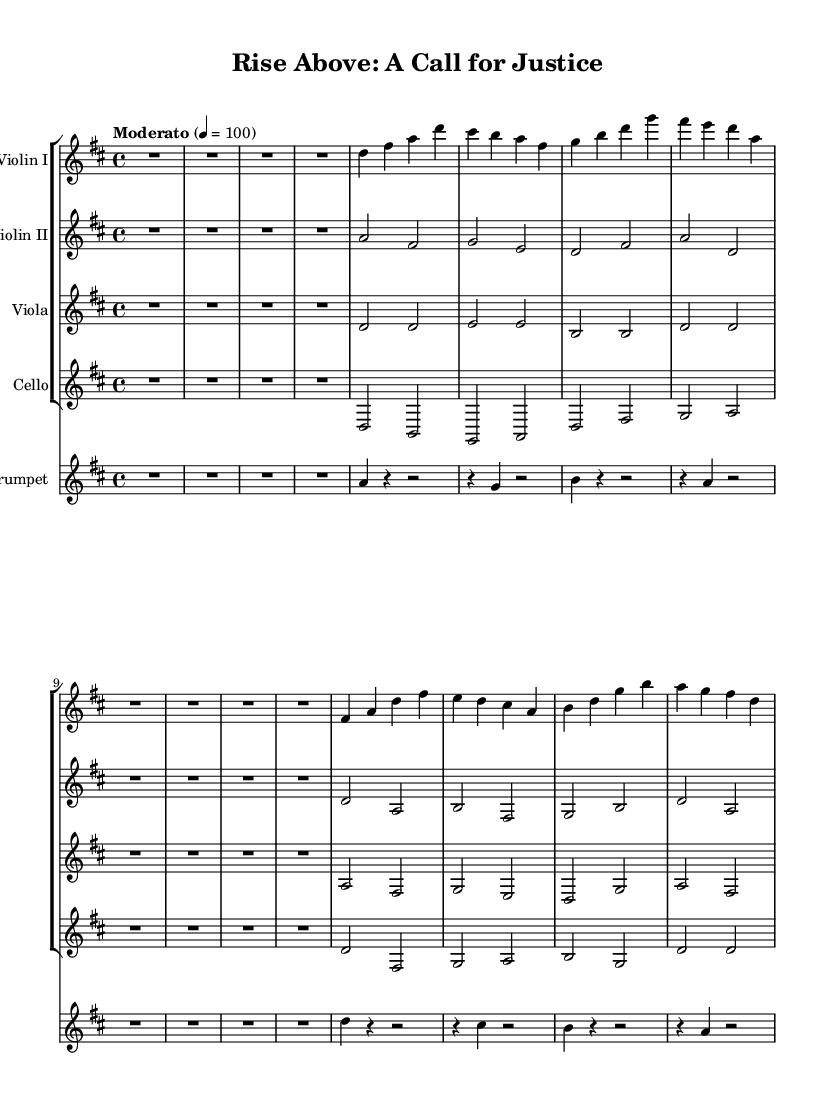What is the key signature of this music? The key signature indicates D major, which has two sharps (F# and C#) as seen at the beginning of the staff.
Answer: D major What is the time signature of this composition? The time signature is 4/4, which means there are four beats in each measure, as indicated by the numbers shown at the beginning of the score.
Answer: 4/4 What is the tempo marking for this piece? The tempo marking "Moderato" appears at the beginning, indicating a moderate speed for the performance.
Answer: Moderato How many main themes are there in this score? The score contains two main themes, labeled as "Main Theme A" and "Main Theme B" in the violin parts.
Answer: Two In which instruments is the Main Theme A played? Main Theme A is played by Violin I, Violin II, Viola, and Cello, as indicated in their respective lines where the theme is marked.
Answer: Violin I, Violin II, Viola, Cello What dynamic contrast can be inferred from the score's structure? The score indicates varied sections without explicit dynamics but does have contrasting themes that suggest emotional variations connected to overcoming adversity. For example, the transition from the Introduction to the Main Themes conveys a journey.
Answer: Contrasting themes What does the bridge section represent in this piece? The bridge section, indicated by "Bridge," serves as a contrasting interlude that prepares the listener for the transition between the main themes, symbolizing resilience.
Answer: Resilience 